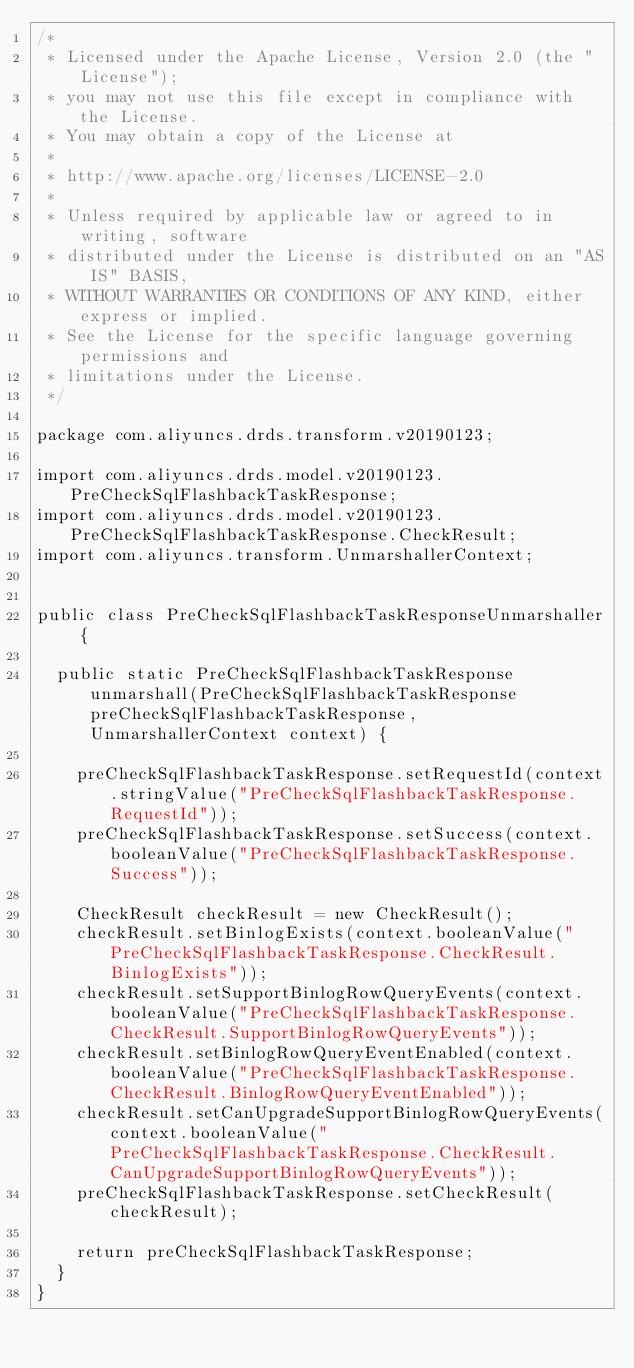<code> <loc_0><loc_0><loc_500><loc_500><_Java_>/*
 * Licensed under the Apache License, Version 2.0 (the "License");
 * you may not use this file except in compliance with the License.
 * You may obtain a copy of the License at
 *
 * http://www.apache.org/licenses/LICENSE-2.0
 *
 * Unless required by applicable law or agreed to in writing, software
 * distributed under the License is distributed on an "AS IS" BASIS,
 * WITHOUT WARRANTIES OR CONDITIONS OF ANY KIND, either express or implied.
 * See the License for the specific language governing permissions and
 * limitations under the License.
 */

package com.aliyuncs.drds.transform.v20190123;

import com.aliyuncs.drds.model.v20190123.PreCheckSqlFlashbackTaskResponse;
import com.aliyuncs.drds.model.v20190123.PreCheckSqlFlashbackTaskResponse.CheckResult;
import com.aliyuncs.transform.UnmarshallerContext;


public class PreCheckSqlFlashbackTaskResponseUnmarshaller {

	public static PreCheckSqlFlashbackTaskResponse unmarshall(PreCheckSqlFlashbackTaskResponse preCheckSqlFlashbackTaskResponse, UnmarshallerContext context) {
		
		preCheckSqlFlashbackTaskResponse.setRequestId(context.stringValue("PreCheckSqlFlashbackTaskResponse.RequestId"));
		preCheckSqlFlashbackTaskResponse.setSuccess(context.booleanValue("PreCheckSqlFlashbackTaskResponse.Success"));

		CheckResult checkResult = new CheckResult();
		checkResult.setBinlogExists(context.booleanValue("PreCheckSqlFlashbackTaskResponse.CheckResult.BinlogExists"));
		checkResult.setSupportBinlogRowQueryEvents(context.booleanValue("PreCheckSqlFlashbackTaskResponse.CheckResult.SupportBinlogRowQueryEvents"));
		checkResult.setBinlogRowQueryEventEnabled(context.booleanValue("PreCheckSqlFlashbackTaskResponse.CheckResult.BinlogRowQueryEventEnabled"));
		checkResult.setCanUpgradeSupportBinlogRowQueryEvents(context.booleanValue("PreCheckSqlFlashbackTaskResponse.CheckResult.CanUpgradeSupportBinlogRowQueryEvents"));
		preCheckSqlFlashbackTaskResponse.setCheckResult(checkResult);
	 
	 	return preCheckSqlFlashbackTaskResponse;
	}
}</code> 